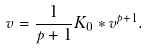Convert formula to latex. <formula><loc_0><loc_0><loc_500><loc_500>v = \frac { 1 } { p + 1 } K _ { 0 } * v ^ { p + 1 } .</formula> 